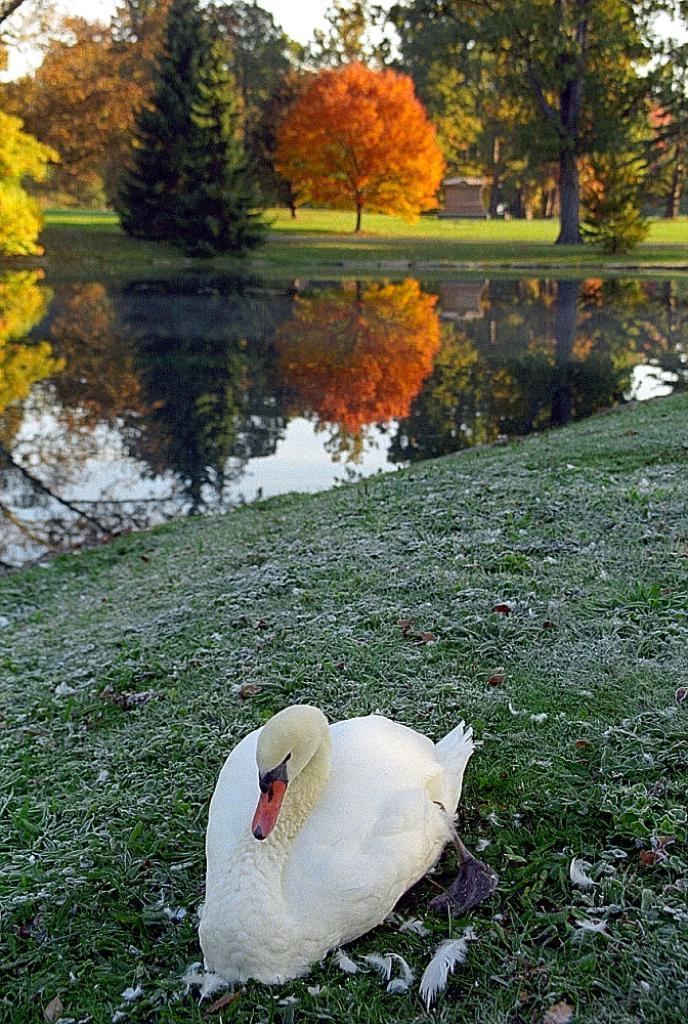How would you summarize this image in a sentence or two? This image is taken outdoors. At the bottom of the image there is a ground with grass on it. In the middle of the image there is a duck on the ground. In the background there are many trees and there is a pond with water. 